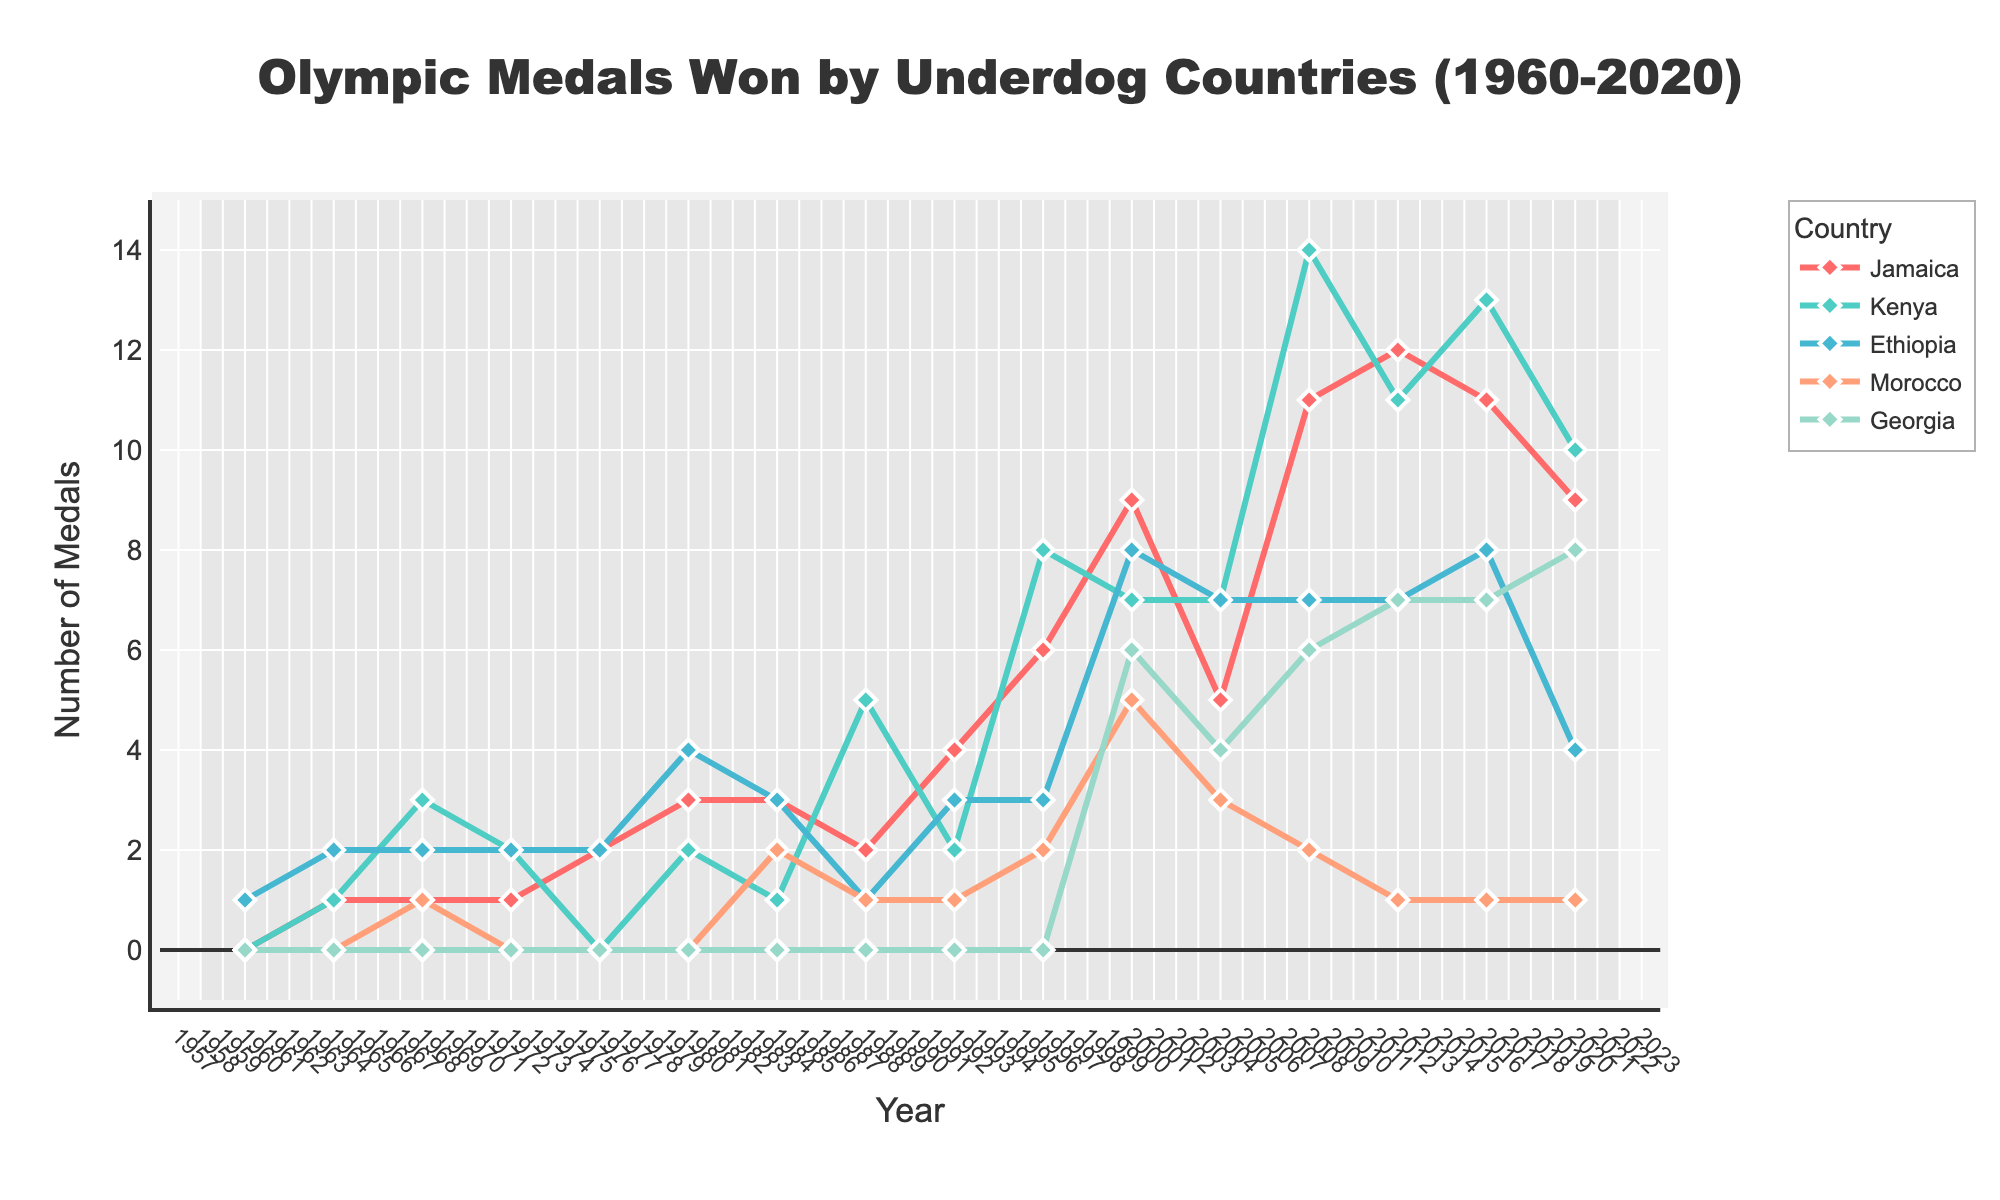Which country won the highest number of Olympic medals in 2012? By examining the lines and points on the chart, you can compare the number of medals each country won in 2012. The highest value corresponds to Jamaica.
Answer: Jamaica How many medals did Kenya and Ethiopia win in total in 2000? To find the total, look at the number of medals won by Kenya (7) and Ethiopia (8) in the year 2000, then sum them up: 7 + 8 = 15.
Answer: 15 Between 1968 and 1972, which country showed a decline in the number of medals won? Identify the lines representing the years 1968 and 1972. By comparing the points for each country, Morocco and Ethiopia's medal counts remained the same, but Kenya's and Jamaica's decreased from 1968 to 1972.
Answer: Jamaica, Kenya In what year did Georgia first win Olympic medals, and how many did they win? Trace the line corresponding to Georgia and find the first year with a positive value. Georgia won its first medals in 2000, with 6 medals.
Answer: 2000, 6 Compare the number of medals won by Jamaica in 2004 versus 2016. Which year saw more success? Count the medals for Jamaica in 2004 (5 medals) and 2016 (11 medals). Comparing the two, 2016 saw more success.
Answer: 2016 What was the difference in the number of Olympic medals won by Ethiopia between 1980 and 2020? Subtract the number of medals won by Ethiopia in 2020 (4 medals) from those won in 1980 (4 medals). The difference is 4 − 4 = 0.
Answer: 0 Which country has the most fluctuating trend in the number of Olympic medals won from 1960 to 2020? Examine the overall trends in the lines for all countries. Jamaica shows the most fluctuations, with significant increases and decreases over time.
Answer: Jamaica In which years did Morocco win only one Olympic medal? Look for the points where Morocco’s line touches the value of 1. These years are 1968, 2012, and 2016.
Answer: 1968, 2012, 2016 How did the medal counts for Kenya and Ethiopia compare in 2008? For 2008, count the medals for Kenya (14) and Ethiopia (7). Kenya's count is higher than Ethiopia's.
Answer: Kenya won more What’s the average number of medals won by Jamaica over the period 1960-2020? Add the number of medals won by Jamaica from each year, then divide by the number of years (15). The sum of medals won is 87, so the average is 87 / 15 ≈ 5.8.
Answer: 5.8 